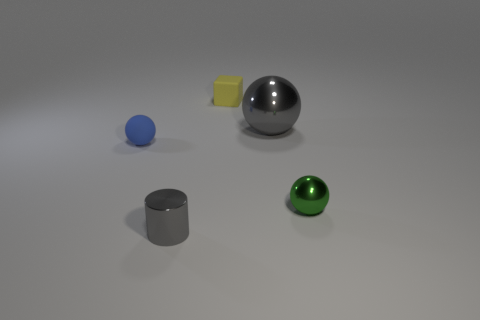Add 4 metal spheres. How many objects exist? 9 Subtract all blocks. How many objects are left? 4 Subtract 0 green blocks. How many objects are left? 5 Subtract all green objects. Subtract all small green shiny objects. How many objects are left? 3 Add 1 blue spheres. How many blue spheres are left? 2 Add 1 blue matte balls. How many blue matte balls exist? 2 